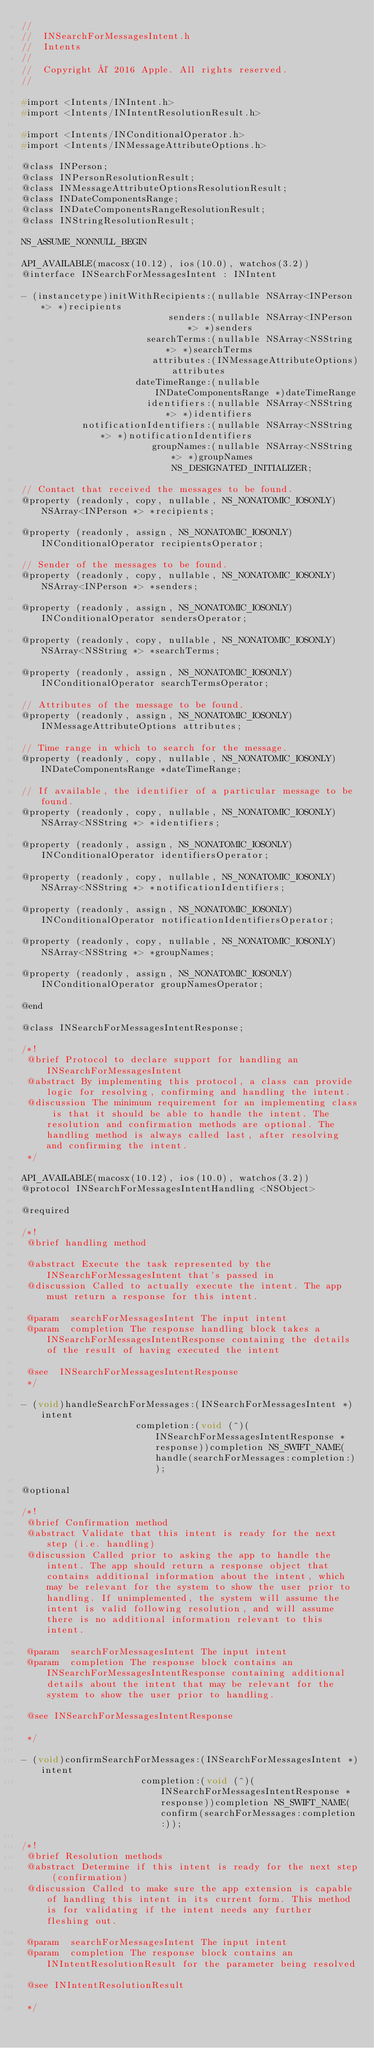<code> <loc_0><loc_0><loc_500><loc_500><_C_>//
//  INSearchForMessagesIntent.h
//  Intents
//
//  Copyright © 2016 Apple. All rights reserved.
//

#import <Intents/INIntent.h>
#import <Intents/INIntentResolutionResult.h>

#import <Intents/INConditionalOperator.h>
#import <Intents/INMessageAttributeOptions.h>

@class INPerson;
@class INPersonResolutionResult;
@class INMessageAttributeOptionsResolutionResult;
@class INDateComponentsRange;
@class INDateComponentsRangeResolutionResult;
@class INStringResolutionResult;

NS_ASSUME_NONNULL_BEGIN

API_AVAILABLE(macosx(10.12), ios(10.0), watchos(3.2))
@interface INSearchForMessagesIntent : INIntent

- (instancetype)initWithRecipients:(nullable NSArray<INPerson *> *)recipients
                           senders:(nullable NSArray<INPerson *> *)senders
                       searchTerms:(nullable NSArray<NSString *> *)searchTerms
                        attributes:(INMessageAttributeOptions)attributes
                     dateTimeRange:(nullable INDateComponentsRange *)dateTimeRange
                       identifiers:(nullable NSArray<NSString *> *)identifiers
           notificationIdentifiers:(nullable NSArray<NSString *> *)notificationIdentifiers
                        groupNames:(nullable NSArray<NSString *> *)groupNames NS_DESIGNATED_INITIALIZER;

// Contact that received the messages to be found.
@property (readonly, copy, nullable, NS_NONATOMIC_IOSONLY) NSArray<INPerson *> *recipients;

@property (readonly, assign, NS_NONATOMIC_IOSONLY) INConditionalOperator recipientsOperator;

// Sender of the messages to be found.
@property (readonly, copy, nullable, NS_NONATOMIC_IOSONLY) NSArray<INPerson *> *senders;

@property (readonly, assign, NS_NONATOMIC_IOSONLY) INConditionalOperator sendersOperator;

@property (readonly, copy, nullable, NS_NONATOMIC_IOSONLY) NSArray<NSString *> *searchTerms;

@property (readonly, assign, NS_NONATOMIC_IOSONLY) INConditionalOperator searchTermsOperator;

// Attributes of the message to be found.
@property (readonly, assign, NS_NONATOMIC_IOSONLY) INMessageAttributeOptions attributes;

// Time range in which to search for the message.
@property (readonly, copy, nullable, NS_NONATOMIC_IOSONLY) INDateComponentsRange *dateTimeRange;

// If available, the identifier of a particular message to be found.
@property (readonly, copy, nullable, NS_NONATOMIC_IOSONLY) NSArray<NSString *> *identifiers;

@property (readonly, assign, NS_NONATOMIC_IOSONLY) INConditionalOperator identifiersOperator;

@property (readonly, copy, nullable, NS_NONATOMIC_IOSONLY) NSArray<NSString *> *notificationIdentifiers;

@property (readonly, assign, NS_NONATOMIC_IOSONLY) INConditionalOperator notificationIdentifiersOperator;

@property (readonly, copy, nullable, NS_NONATOMIC_IOSONLY) NSArray<NSString *> *groupNames;

@property (readonly, assign, NS_NONATOMIC_IOSONLY) INConditionalOperator groupNamesOperator;

@end

@class INSearchForMessagesIntentResponse;

/*!
 @brief Protocol to declare support for handling an INSearchForMessagesIntent 
 @abstract By implementing this protocol, a class can provide logic for resolving, confirming and handling the intent.
 @discussion The minimum requirement for an implementing class is that it should be able to handle the intent. The resolution and confirmation methods are optional. The handling method is always called last, after resolving and confirming the intent.
 */

API_AVAILABLE(macosx(10.12), ios(10.0), watchos(3.2))
@protocol INSearchForMessagesIntentHandling <NSObject>

@required

/*!
 @brief handling method

 @abstract Execute the task represented by the INSearchForMessagesIntent that's passed in
 @discussion Called to actually execute the intent. The app must return a response for this intent.

 @param  searchForMessagesIntent The input intent
 @param  completion The response handling block takes a INSearchForMessagesIntentResponse containing the details of the result of having executed the intent

 @see  INSearchForMessagesIntentResponse
 */

- (void)handleSearchForMessages:(INSearchForMessagesIntent *)intent
                     completion:(void (^)(INSearchForMessagesIntentResponse *response))completion NS_SWIFT_NAME(handle(searchForMessages:completion:));

@optional

/*!
 @brief Confirmation method
 @abstract Validate that this intent is ready for the next step (i.e. handling)
 @discussion Called prior to asking the app to handle the intent. The app should return a response object that contains additional information about the intent, which may be relevant for the system to show the user prior to handling. If unimplemented, the system will assume the intent is valid following resolution, and will assume there is no additional information relevant to this intent.

 @param  searchForMessagesIntent The input intent
 @param  completion The response block contains an INSearchForMessagesIntentResponse containing additional details about the intent that may be relevant for the system to show the user prior to handling.

 @see INSearchForMessagesIntentResponse

 */

- (void)confirmSearchForMessages:(INSearchForMessagesIntent *)intent
                      completion:(void (^)(INSearchForMessagesIntentResponse *response))completion NS_SWIFT_NAME(confirm(searchForMessages:completion:));

/*!
 @brief Resolution methods
 @abstract Determine if this intent is ready for the next step (confirmation)
 @discussion Called to make sure the app extension is capable of handling this intent in its current form. This method is for validating if the intent needs any further fleshing out.

 @param  searchForMessagesIntent The input intent
 @param  completion The response block contains an INIntentResolutionResult for the parameter being resolved

 @see INIntentResolutionResult

 */
</code> 